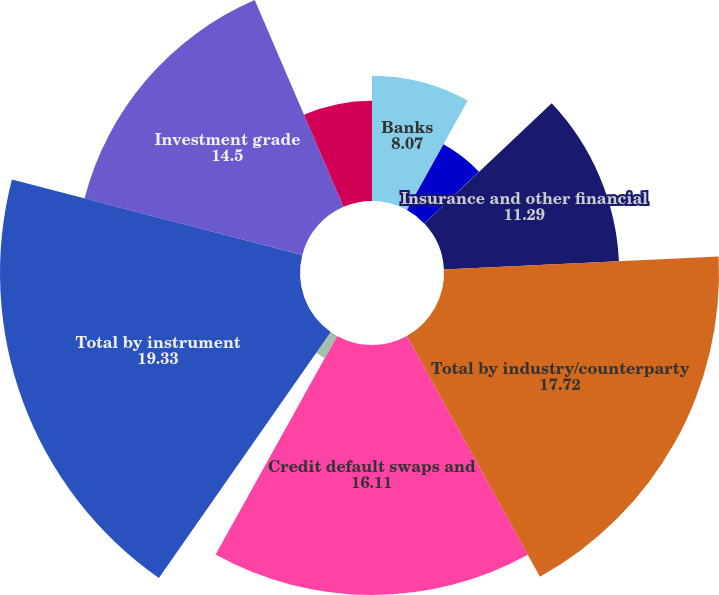<chart> <loc_0><loc_0><loc_500><loc_500><pie_chart><fcel>Banks<fcel>Broker-dealers<fcel>Non-financial<fcel>Insurance and other financial<fcel>Total by industry/counterparty<fcel>Credit default swaps and<fcel>Total return swaps and other<fcel>Total by instrument<fcel>Investment grade<fcel>Non-investment grade<nl><fcel>8.07%<fcel>4.85%<fcel>0.03%<fcel>11.29%<fcel>17.72%<fcel>16.11%<fcel>1.64%<fcel>19.33%<fcel>14.5%<fcel>6.46%<nl></chart> 